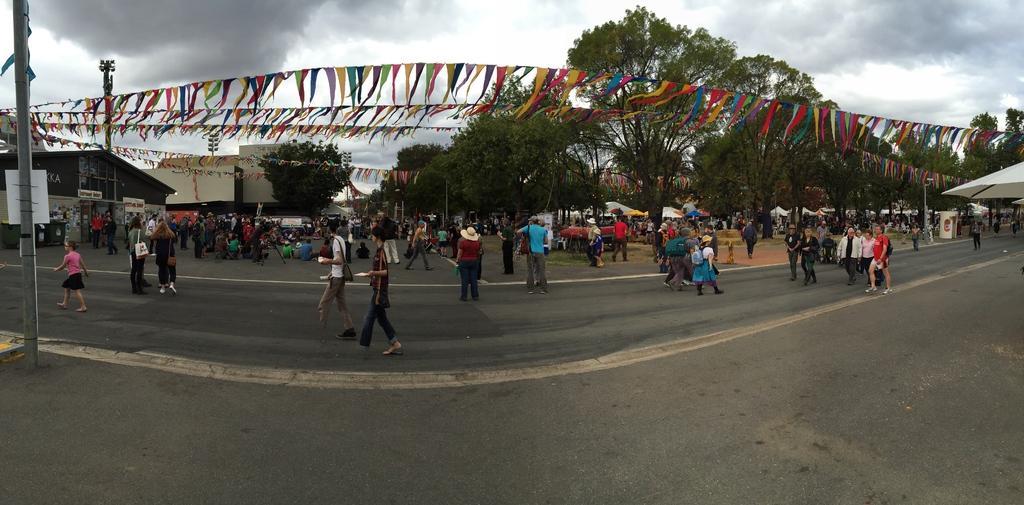Describe this image in one or two sentences. In this picture we can see a group of people on the road and in the background we can see buildings,trees,sky. 